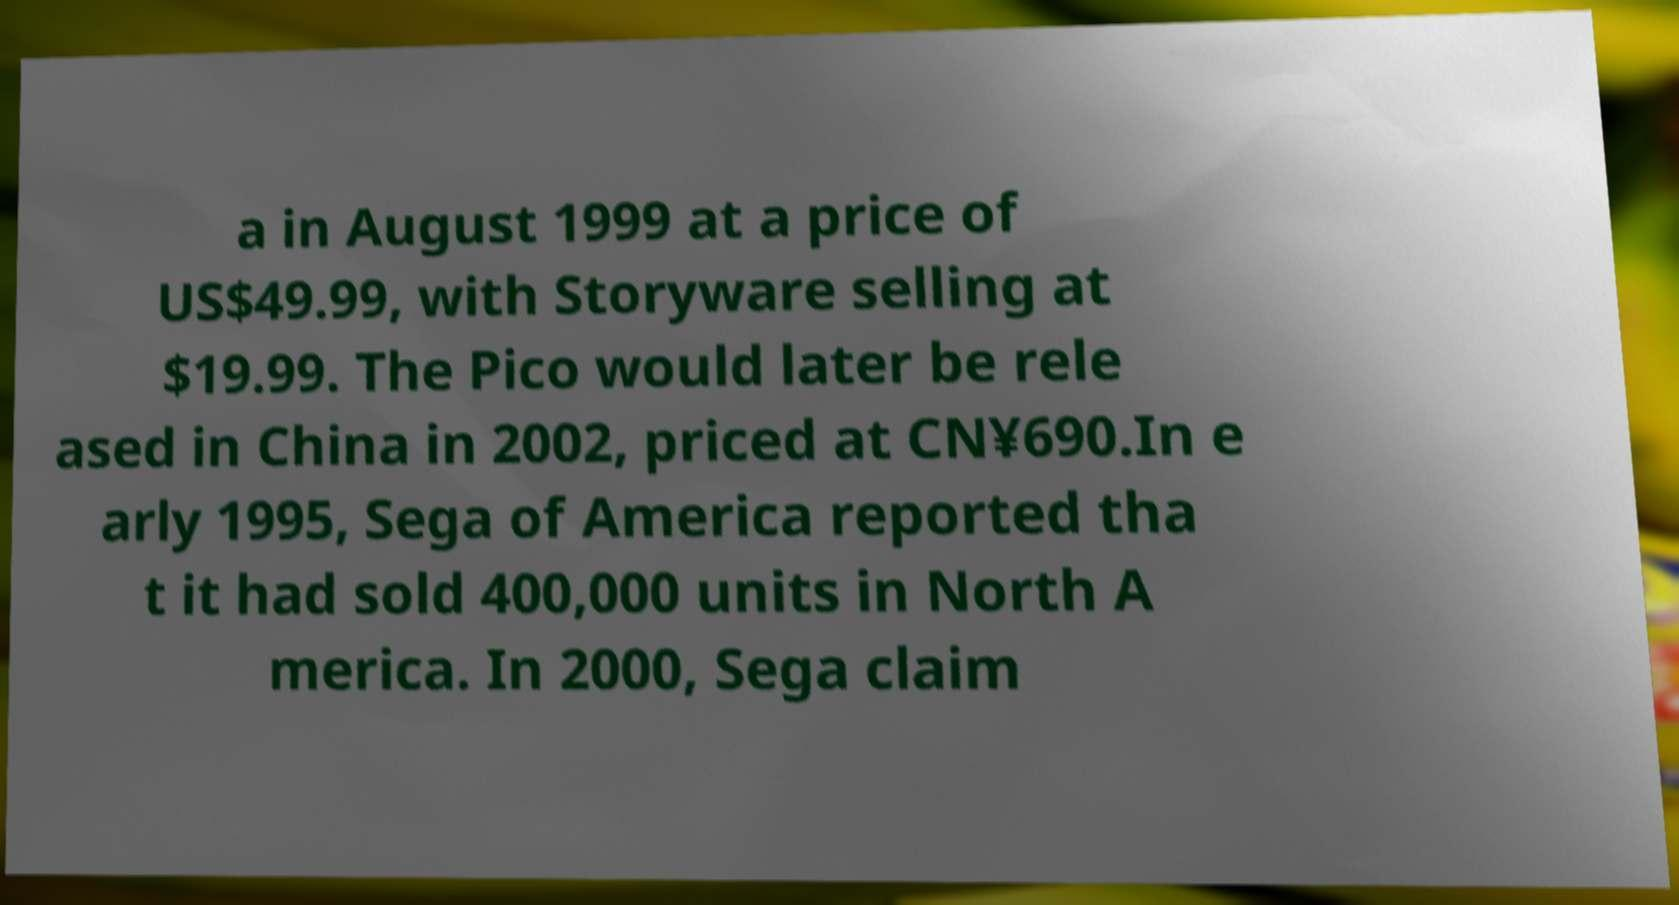I need the written content from this picture converted into text. Can you do that? a in August 1999 at a price of US$49.99, with Storyware selling at $19.99. The Pico would later be rele ased in China in 2002, priced at CN¥690.In e arly 1995, Sega of America reported tha t it had sold 400,000 units in North A merica. In 2000, Sega claim 